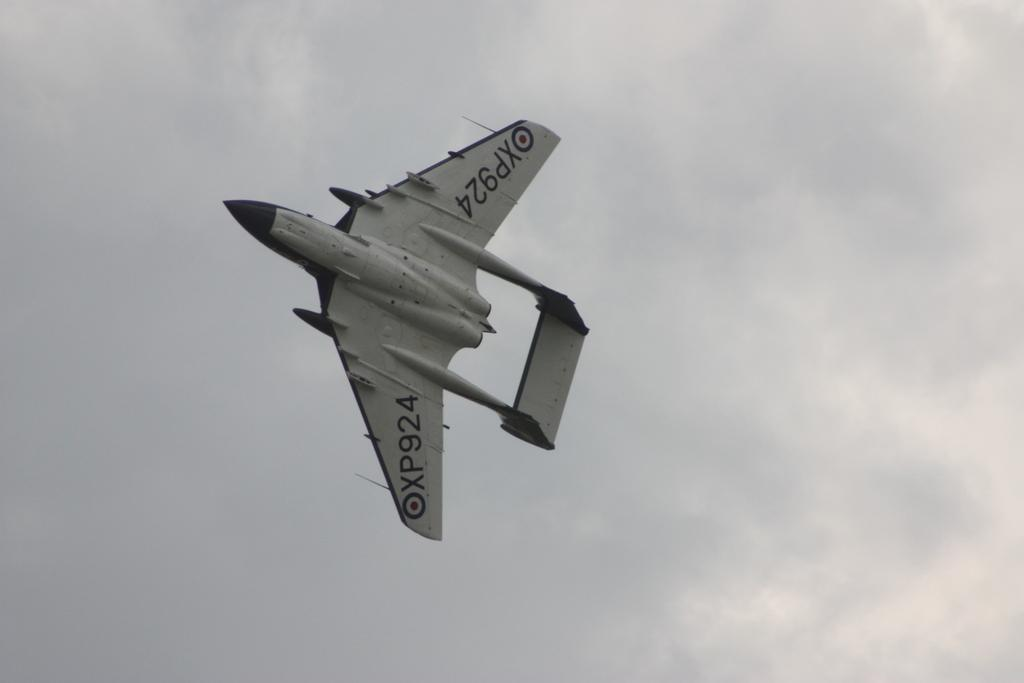<image>
Share a concise interpretation of the image provided. the plane is flying at an angle allowing the numbers ont he bottom to be seen as XP924 